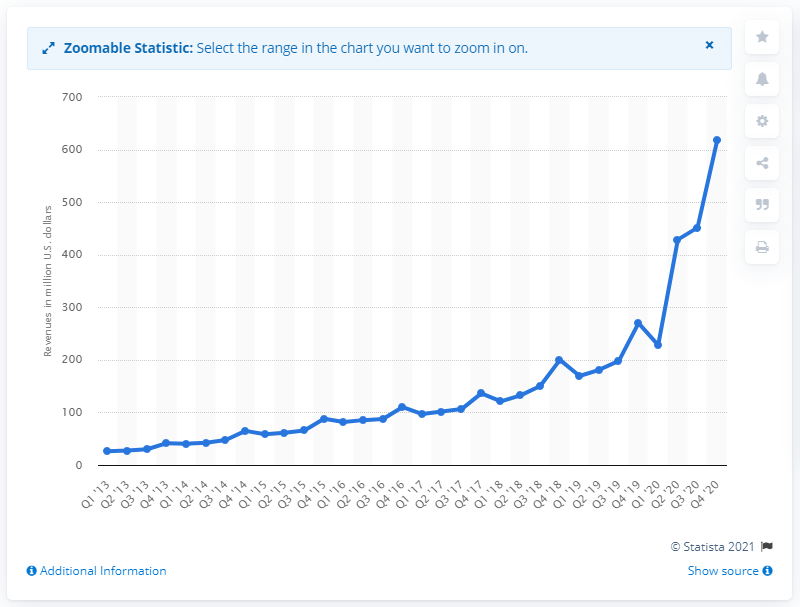Identify some key points in this picture. Etsy's revenue in the previous quarter was 451.48. Etsy generated $617.36 million in revenue during the fourth quarter of 2020. 